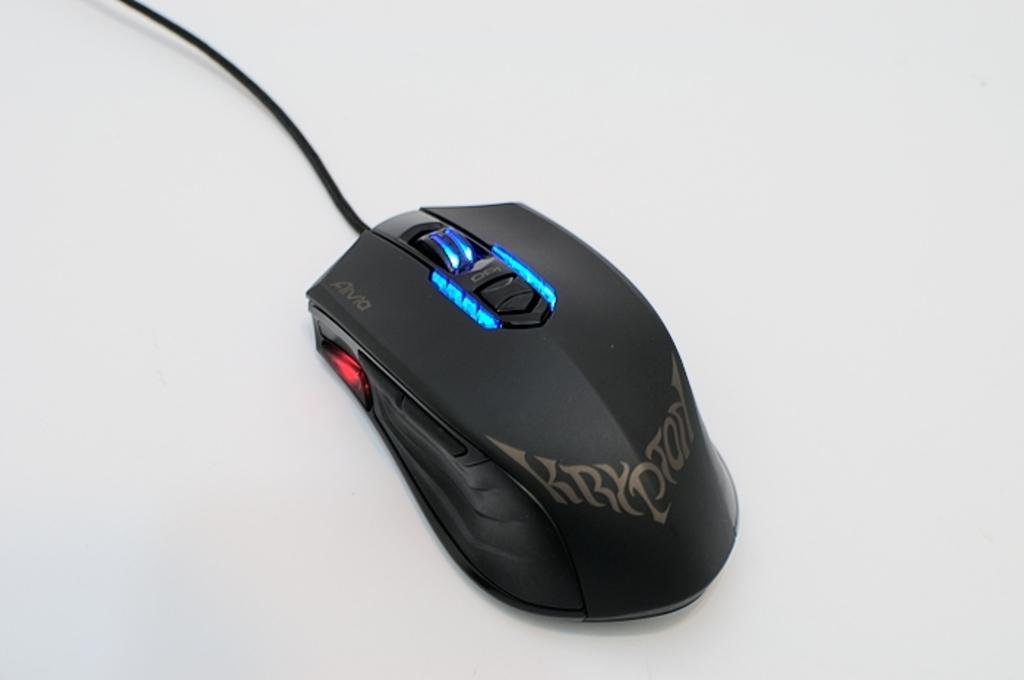<image>
Share a concise interpretation of the image provided. A black Krypton mouse is sitting on a gray surface 